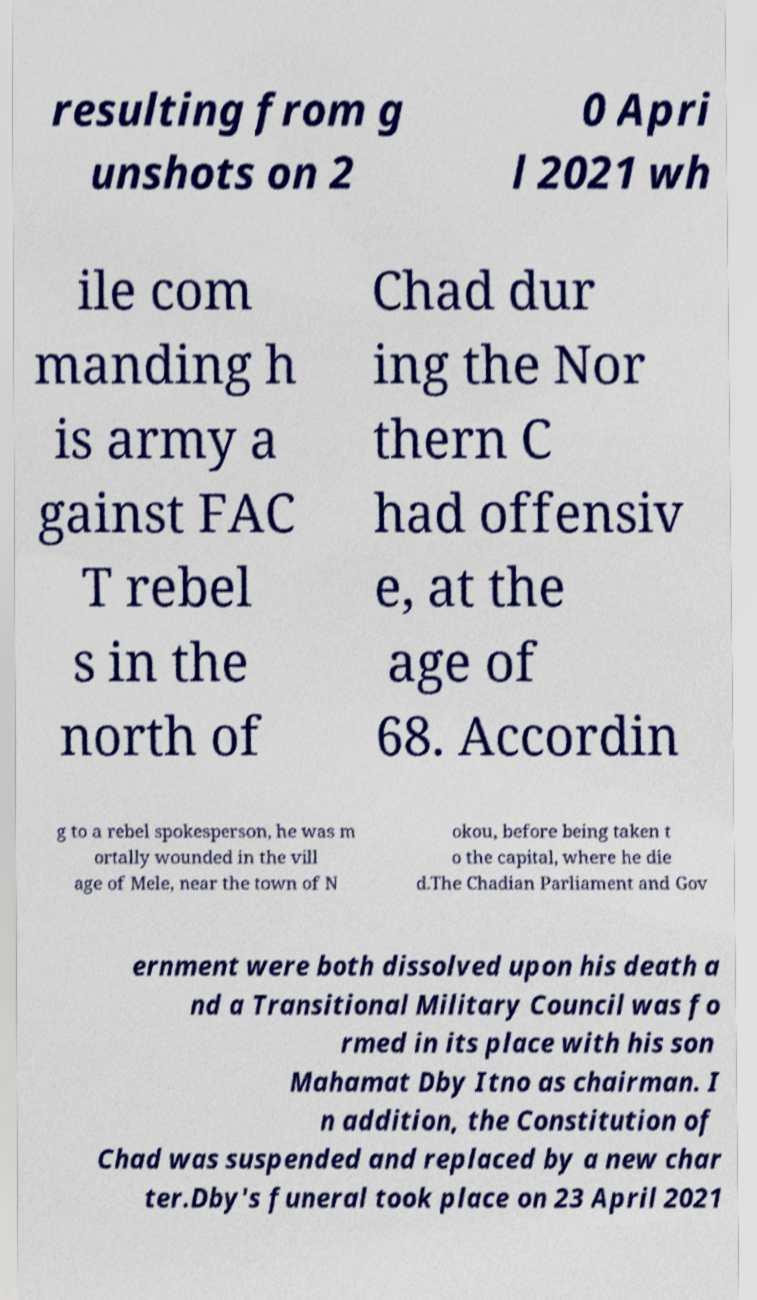Could you assist in decoding the text presented in this image and type it out clearly? resulting from g unshots on 2 0 Apri l 2021 wh ile com manding h is army a gainst FAC T rebel s in the north of Chad dur ing the Nor thern C had offensiv e, at the age of 68. Accordin g to a rebel spokesperson, he was m ortally wounded in the vill age of Mele, near the town of N okou, before being taken t o the capital, where he die d.The Chadian Parliament and Gov ernment were both dissolved upon his death a nd a Transitional Military Council was fo rmed in its place with his son Mahamat Dby Itno as chairman. I n addition, the Constitution of Chad was suspended and replaced by a new char ter.Dby's funeral took place on 23 April 2021 